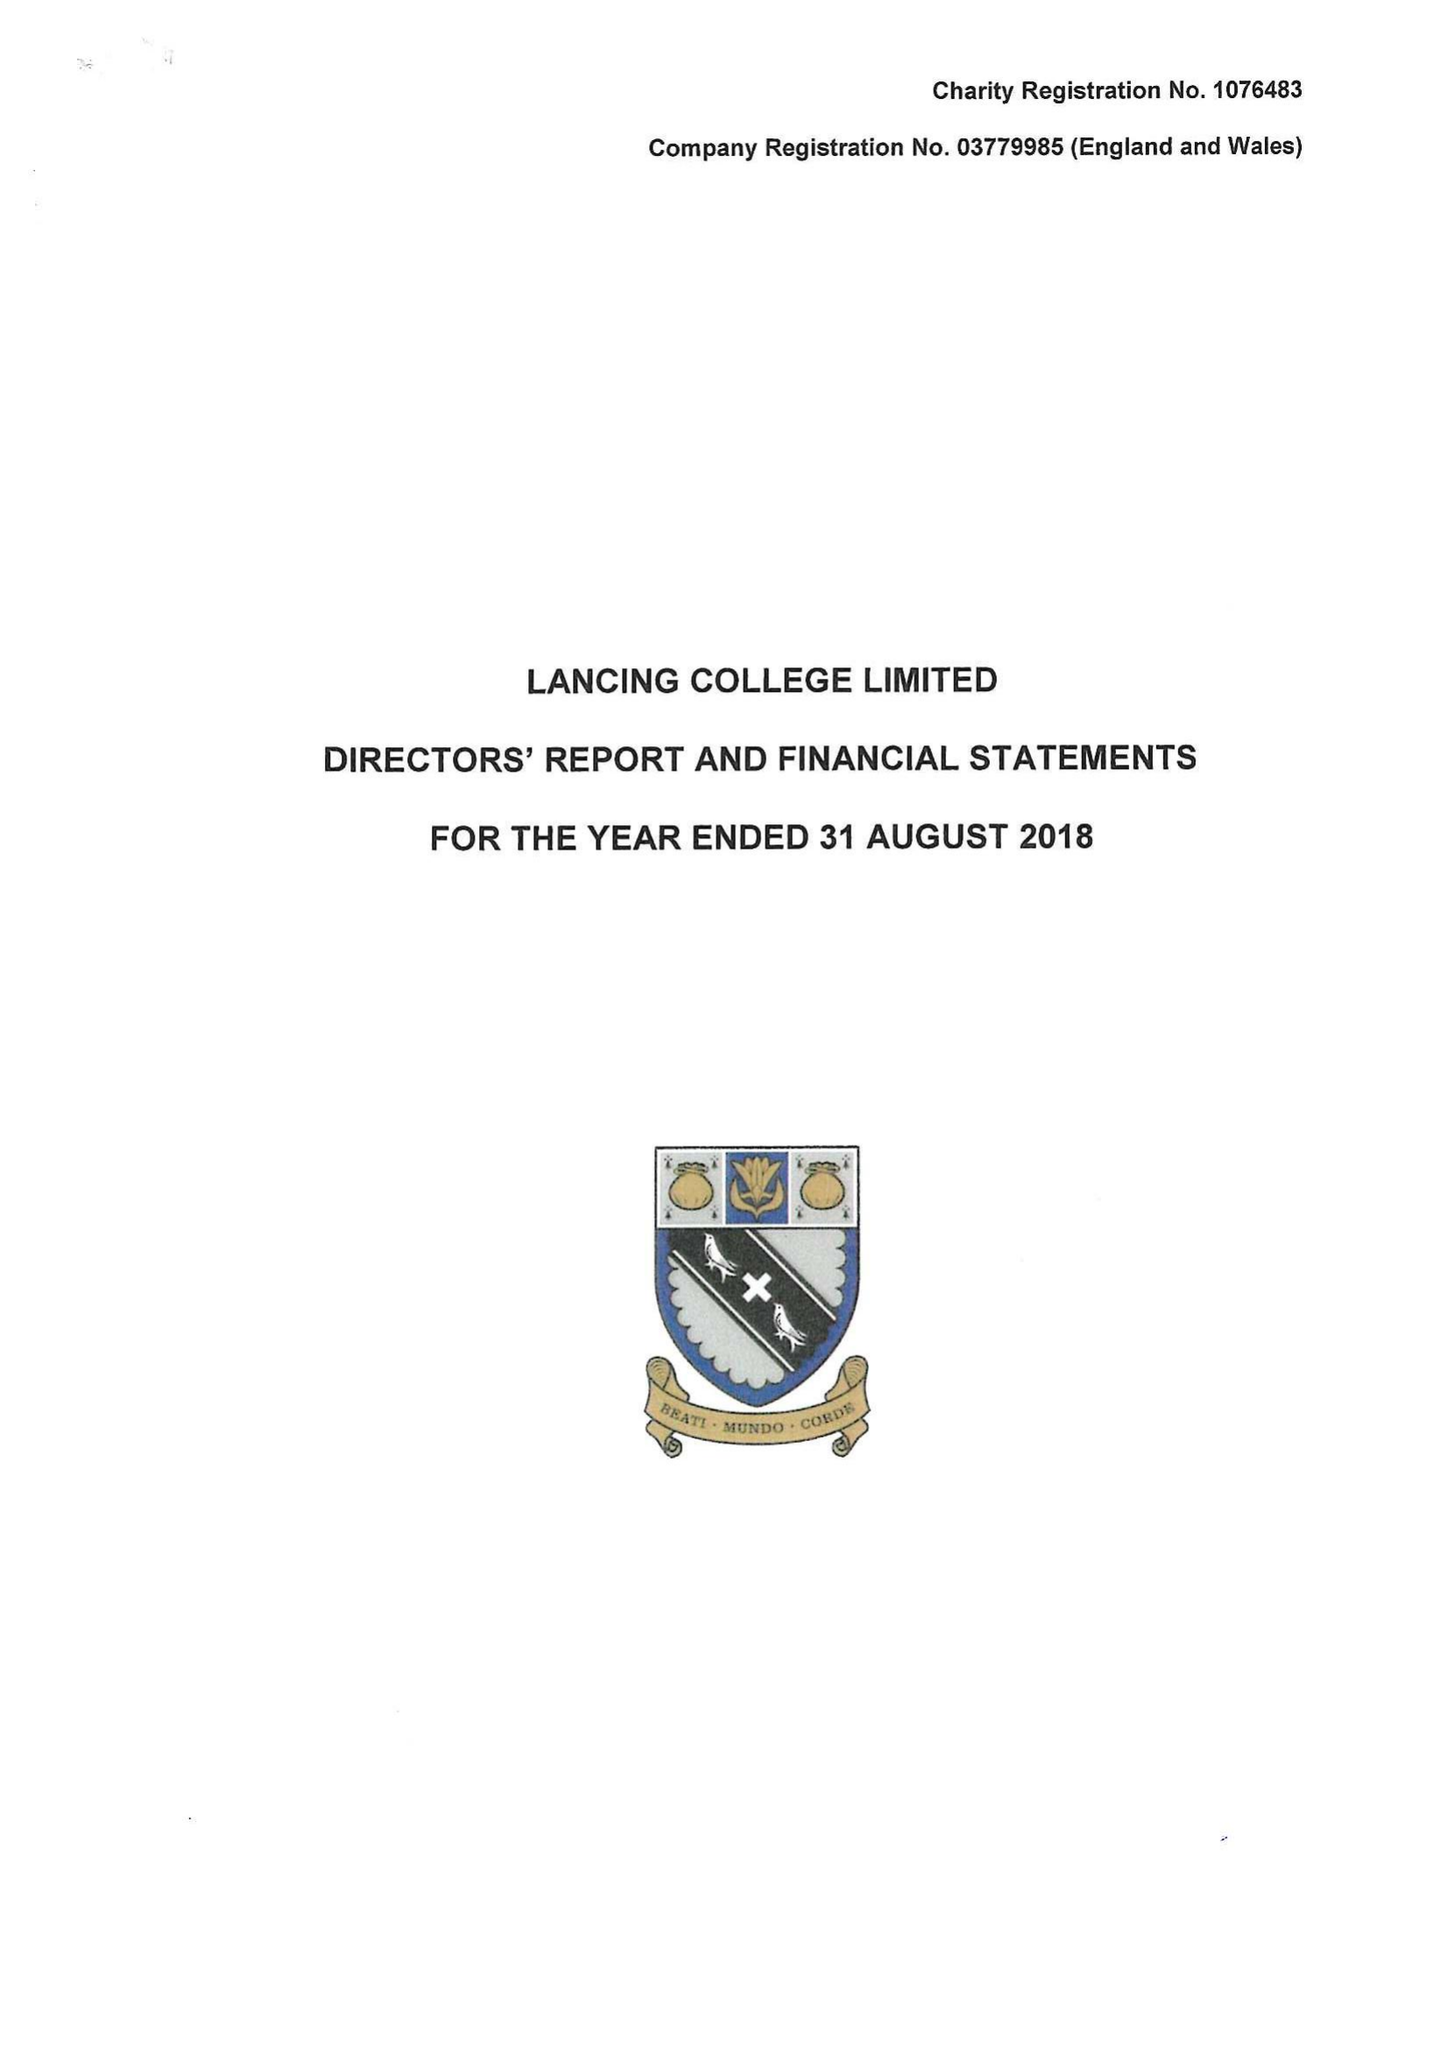What is the value for the charity_name?
Answer the question using a single word or phrase. Lancing College Ltd. 